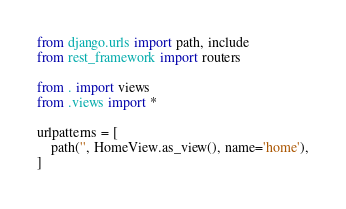Convert code to text. <code><loc_0><loc_0><loc_500><loc_500><_Python_>from django.urls import path, include
from rest_framework import routers

from . import views
from .views import *

urlpatterns = [
    path('', HomeView.as_view(), name='home'),
]
</code> 